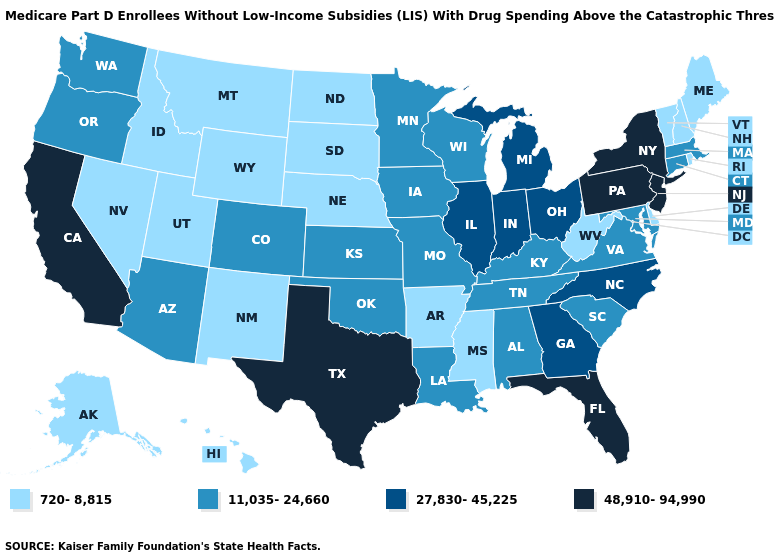Does the first symbol in the legend represent the smallest category?
Write a very short answer. Yes. Among the states that border New York , which have the highest value?
Quick response, please. New Jersey, Pennsylvania. Among the states that border Vermont , which have the highest value?
Be succinct. New York. What is the lowest value in the MidWest?
Quick response, please. 720-8,815. Which states have the lowest value in the USA?
Write a very short answer. Alaska, Arkansas, Delaware, Hawaii, Idaho, Maine, Mississippi, Montana, Nebraska, Nevada, New Hampshire, New Mexico, North Dakota, Rhode Island, South Dakota, Utah, Vermont, West Virginia, Wyoming. What is the value of North Dakota?
Concise answer only. 720-8,815. Among the states that border South Dakota , which have the lowest value?
Give a very brief answer. Montana, Nebraska, North Dakota, Wyoming. What is the value of Idaho?
Concise answer only. 720-8,815. What is the value of Tennessee?
Be succinct. 11,035-24,660. Among the states that border Michigan , does Indiana have the highest value?
Keep it brief. Yes. Does Michigan have the same value as Georgia?
Be succinct. Yes. Among the states that border Ohio , which have the lowest value?
Write a very short answer. West Virginia. What is the value of Missouri?
Write a very short answer. 11,035-24,660. Name the states that have a value in the range 27,830-45,225?
Short answer required. Georgia, Illinois, Indiana, Michigan, North Carolina, Ohio. 